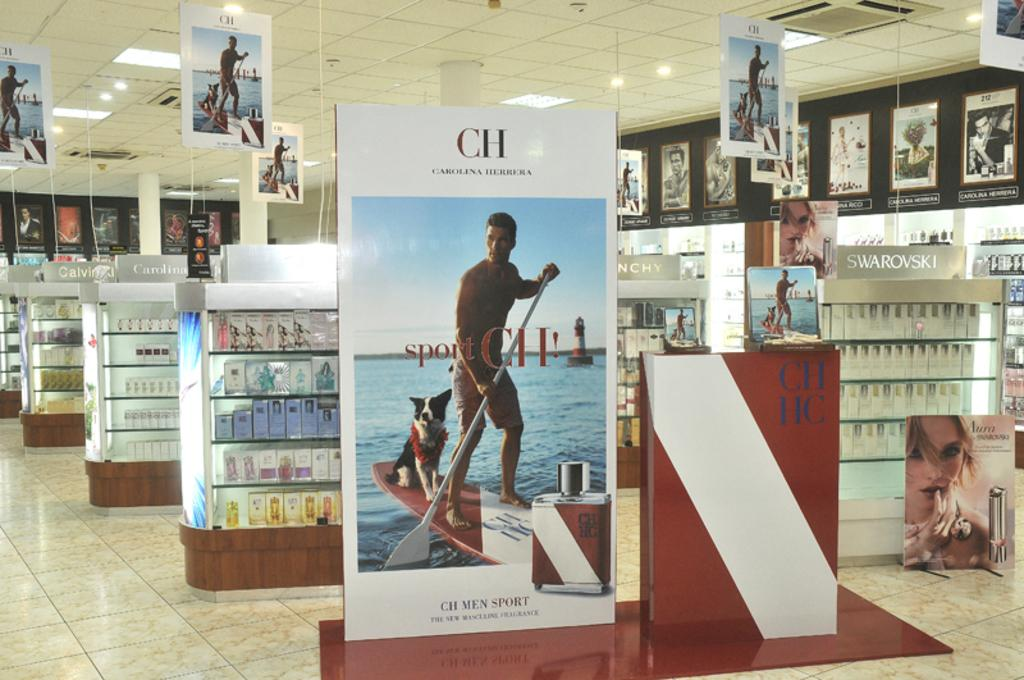Provide a one-sentence caption for the provided image. a cosmetic store with a CH commercial board at the front. 